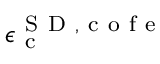<formula> <loc_0><loc_0><loc_500><loc_500>\epsilon _ { c } ^ { { S D } , c o f e }</formula> 